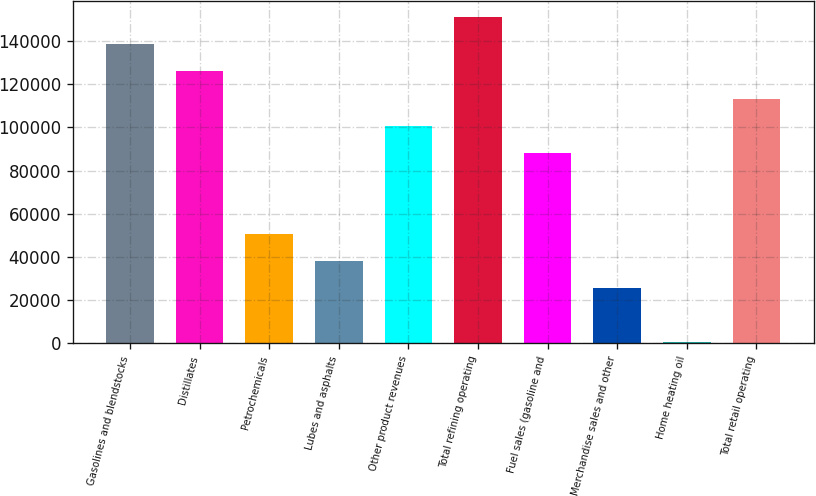<chart> <loc_0><loc_0><loc_500><loc_500><bar_chart><fcel>Gasolines and blendstocks<fcel>Distillates<fcel>Petrochemicals<fcel>Lubes and asphalts<fcel>Other product revenues<fcel>Total refining operating<fcel>Fuel sales (gasoline and<fcel>Merchandise sales and other<fcel>Home heating oil<fcel>Total retail operating<nl><fcel>138552<fcel>125987<fcel>50595.2<fcel>38029.9<fcel>100856<fcel>151118<fcel>88291.1<fcel>25464.6<fcel>334<fcel>113422<nl></chart> 